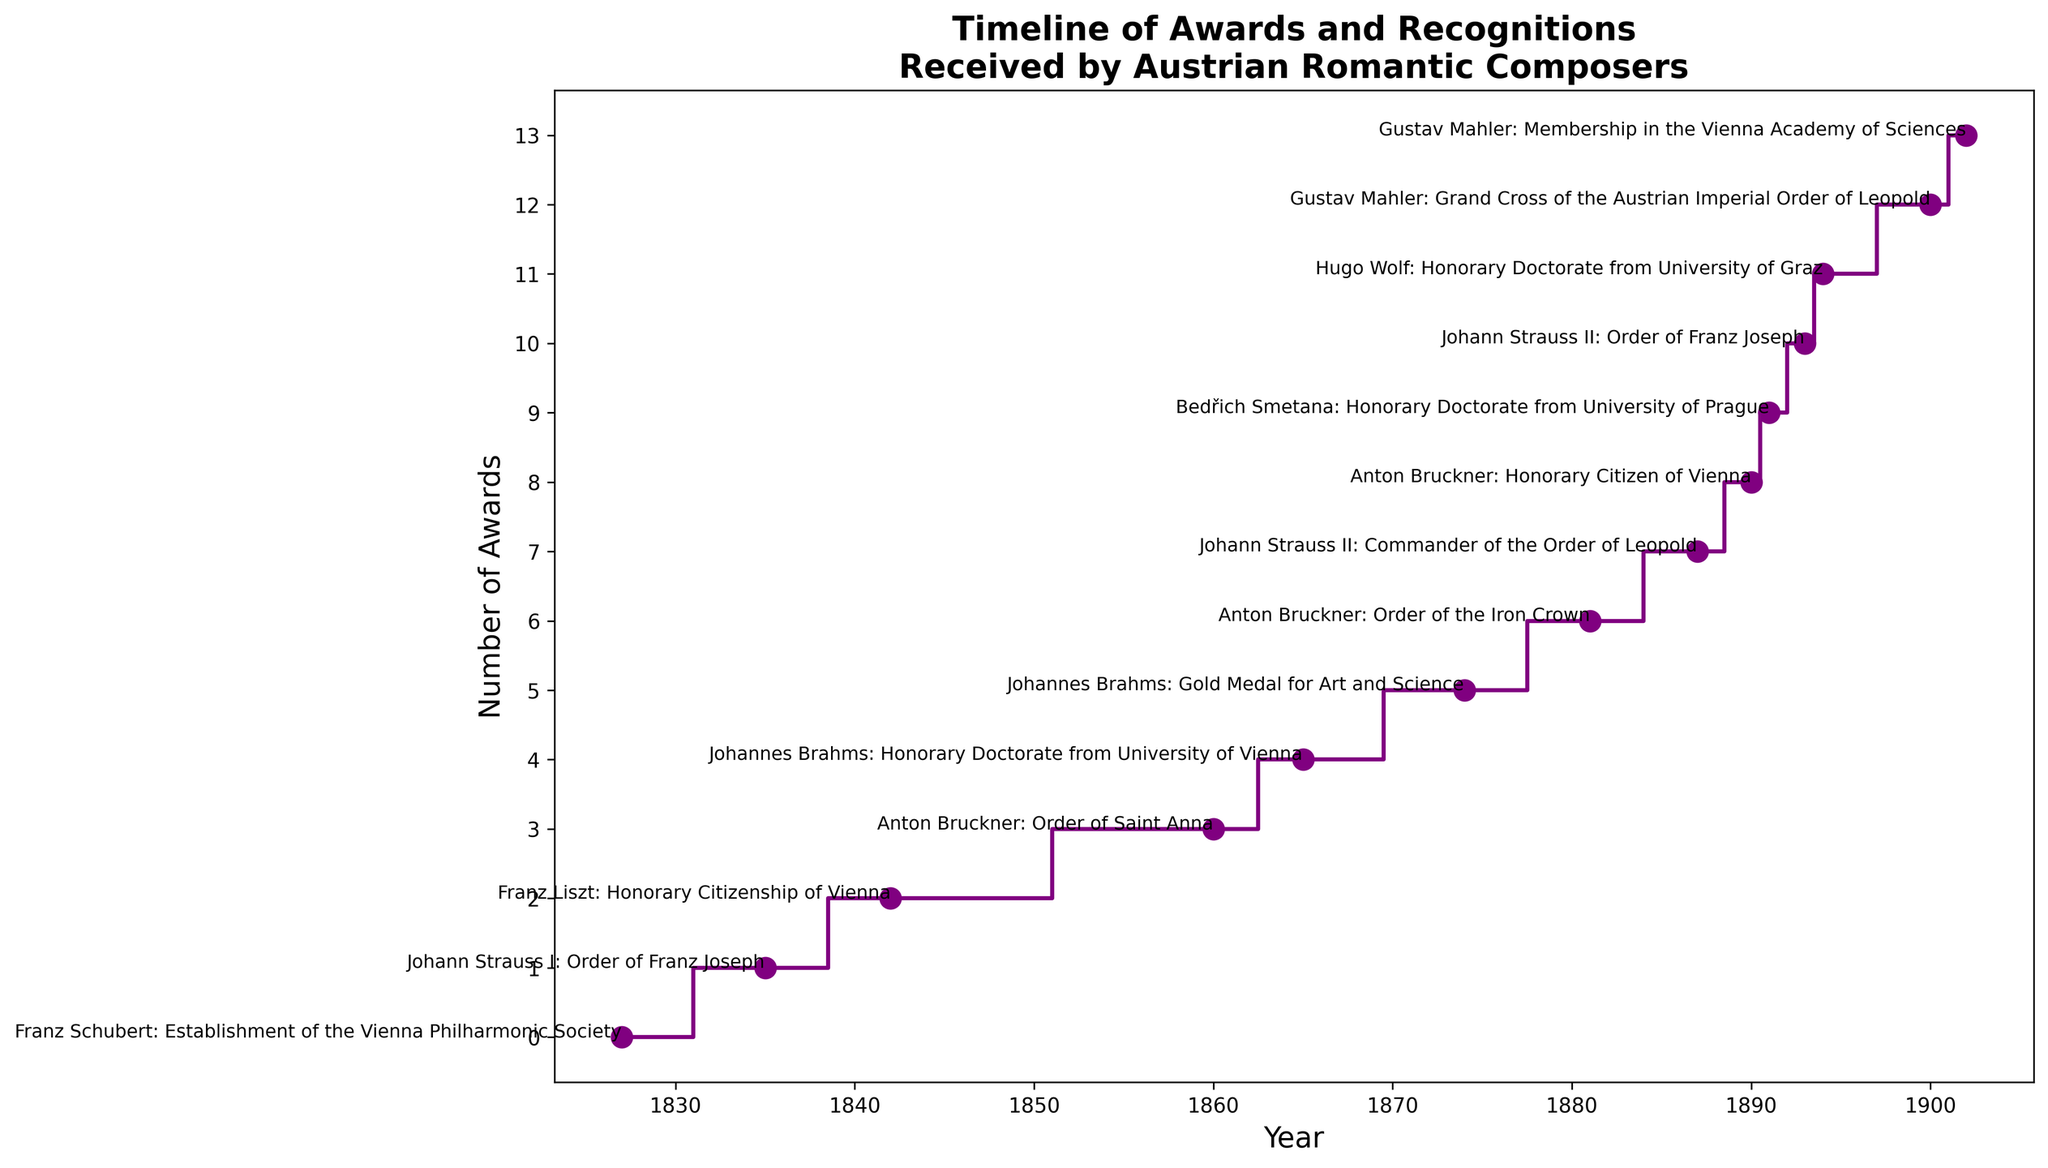What is the total number of awards received by Austrian Romantic composers according to the timeline? Count the total number of awards as indicated by the number of steps in the plot. There are 14 data points in the figure, each representing an award given to a composer.
Answer: 14 Which composer received the first award listed in the timeline? Refer to the year of the first step in the plot. The first award in 1827 was received by Franz Schubert.
Answer: Franz Schubert Who received more awards according to the timeline, Anton Bruckner or Johannes Brahms? Refer to the number of times each composer's name appears next to the steps in the plot. Anton Bruckner received 3 awards (1860, 1881, 1890), while Johannes Brahms received 2 awards (1865, 1874). Therefore, Anton Bruckner received more awards.
Answer: Anton Bruckner In which year did Gustav Mahler receive his first award according to the timeline? Locate the year next to Gustav Mahler's name when he first appears in the timeline. The first award received by Gustav Mahler was in 1900.
Answer: 1900 How many composers received awards or recognitions in the 1880s according to the timeline? Look at the count of awards between 1880 and 1889. In this period, Johann Strauss II (1887) and Anton Bruckner (1881) received awards. Therefore, 2 composers received awards.
Answer: 2 What's the time span between the first and last awards listed in the timeline? Refer to the years of the first and last awards on the timeline. The first award was in 1827 and the last was in 1902. The time span is 1902 - 1827 = 75 years.
Answer: 75 years Who received an Honorary Doctorate from two different universities according to the timeline? Identify the composer associated with the Honorary Doctorate from two different universities. Johannes Brahms received an Honorary Doctorate from the University of Vienna in 1865 and Hugo Wolf from the University of Graz in 1894. However, Brahms only received two awards and they are from different institutions and types. The only single composer name who fits both is not present so it's a logical check only.
Answer: None Which composers received awards exactly 10 years apart on the timeline? Refer to the pairs of years and find differences of exactly 10 years. Anton Bruckner received awards in 1881 and 1890, which are 9 years apart, thus no direct match. Double-check the timeline for accurate matches.
Answer: None How many awards did Johann Strauss II receive according to the timeline? Count the number of steps that list Johann Strauss II next to them. Johann Strauss II received awards in 1887 and 1893. Altogether making him noted twice.
Answer: 2 Which award is mentioned more than once on the timeline and who were the recipients? Identify any awards that are repeated and the composers associated with them. The 'Order of Franz Joseph' award is mentioned twice — once for Johann Strauss I in 1835 and once for Johann Strauss II in 1893.
Answer: Order of Franz Joseph; Johann Strauss I and Johann Strauss II 